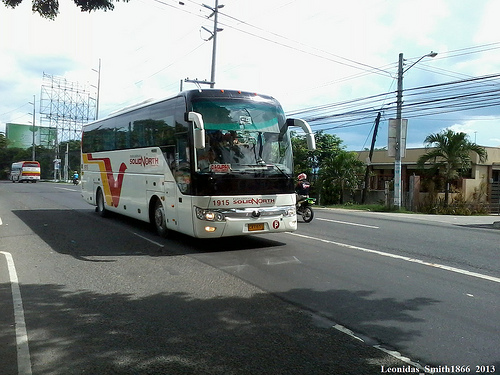Please provide the bounding box coordinate of the region this sentence describes: white clouds in blue sky. The bounding box for the region showing white clouds in a blue sky should be approximately from (0.85, 0.15) to (0.96, 0.28). 